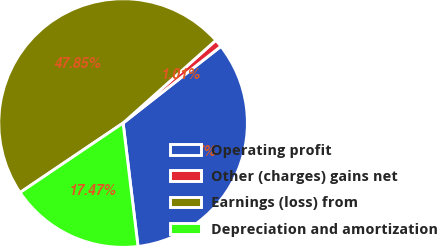<chart> <loc_0><loc_0><loc_500><loc_500><pie_chart><fcel>Operating profit<fcel>Other (charges) gains net<fcel>Earnings (loss) from<fcel>Depreciation and amortization<nl><fcel>33.67%<fcel>1.01%<fcel>47.85%<fcel>17.47%<nl></chart> 